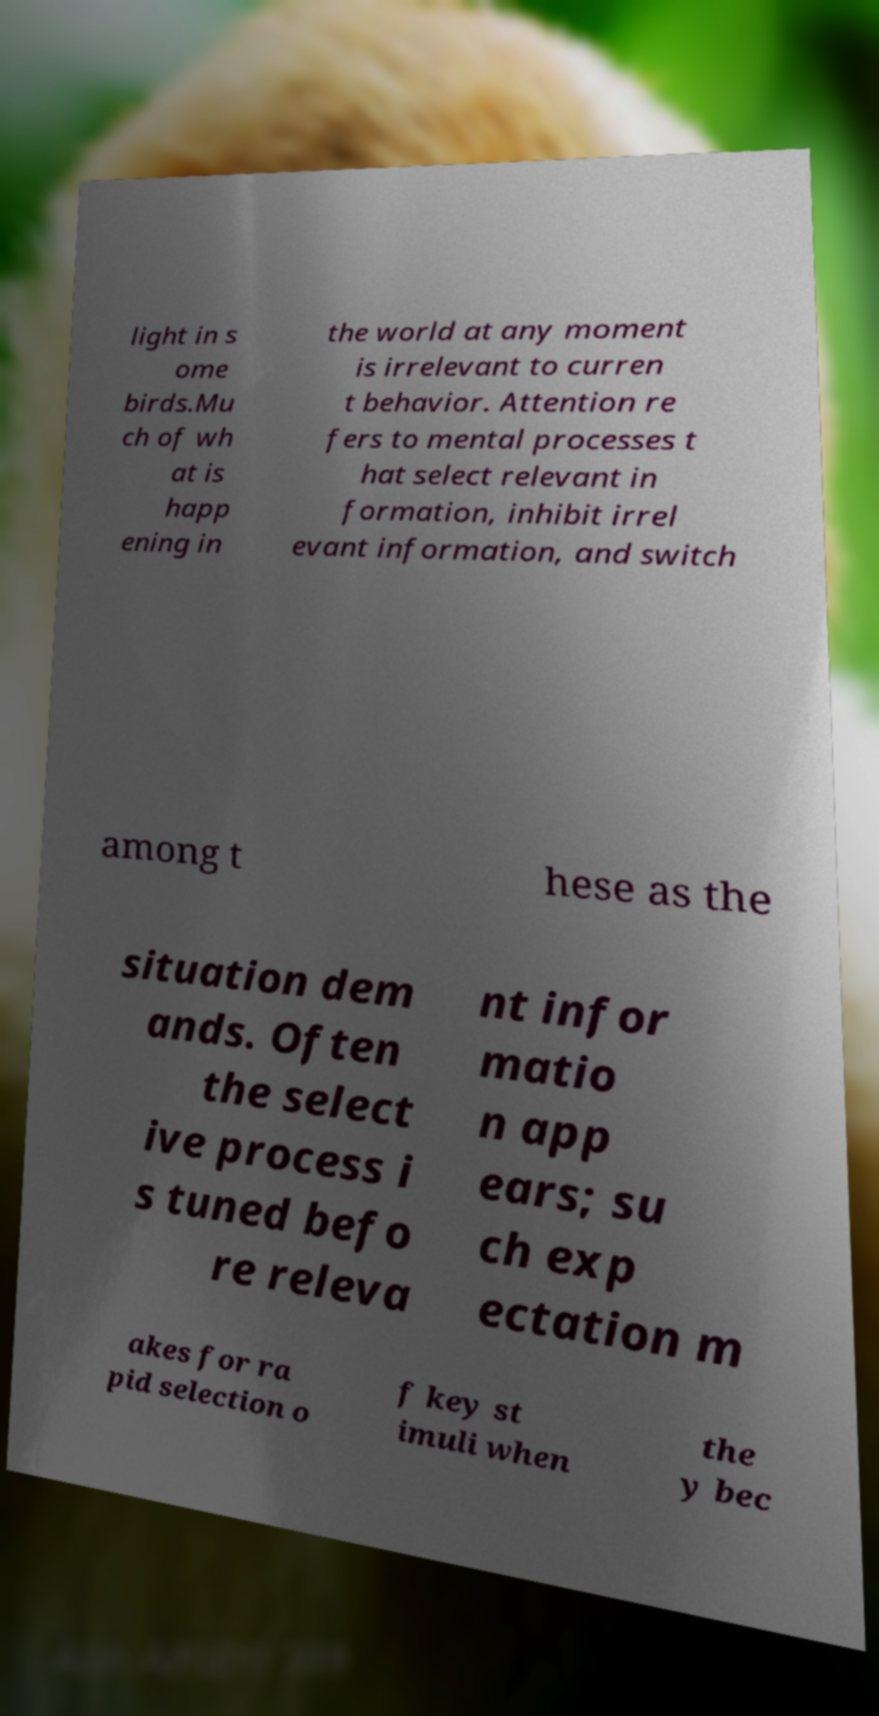Can you read and provide the text displayed in the image?This photo seems to have some interesting text. Can you extract and type it out for me? light in s ome birds.Mu ch of wh at is happ ening in the world at any moment is irrelevant to curren t behavior. Attention re fers to mental processes t hat select relevant in formation, inhibit irrel evant information, and switch among t hese as the situation dem ands. Often the select ive process i s tuned befo re releva nt infor matio n app ears; su ch exp ectation m akes for ra pid selection o f key st imuli when the y bec 